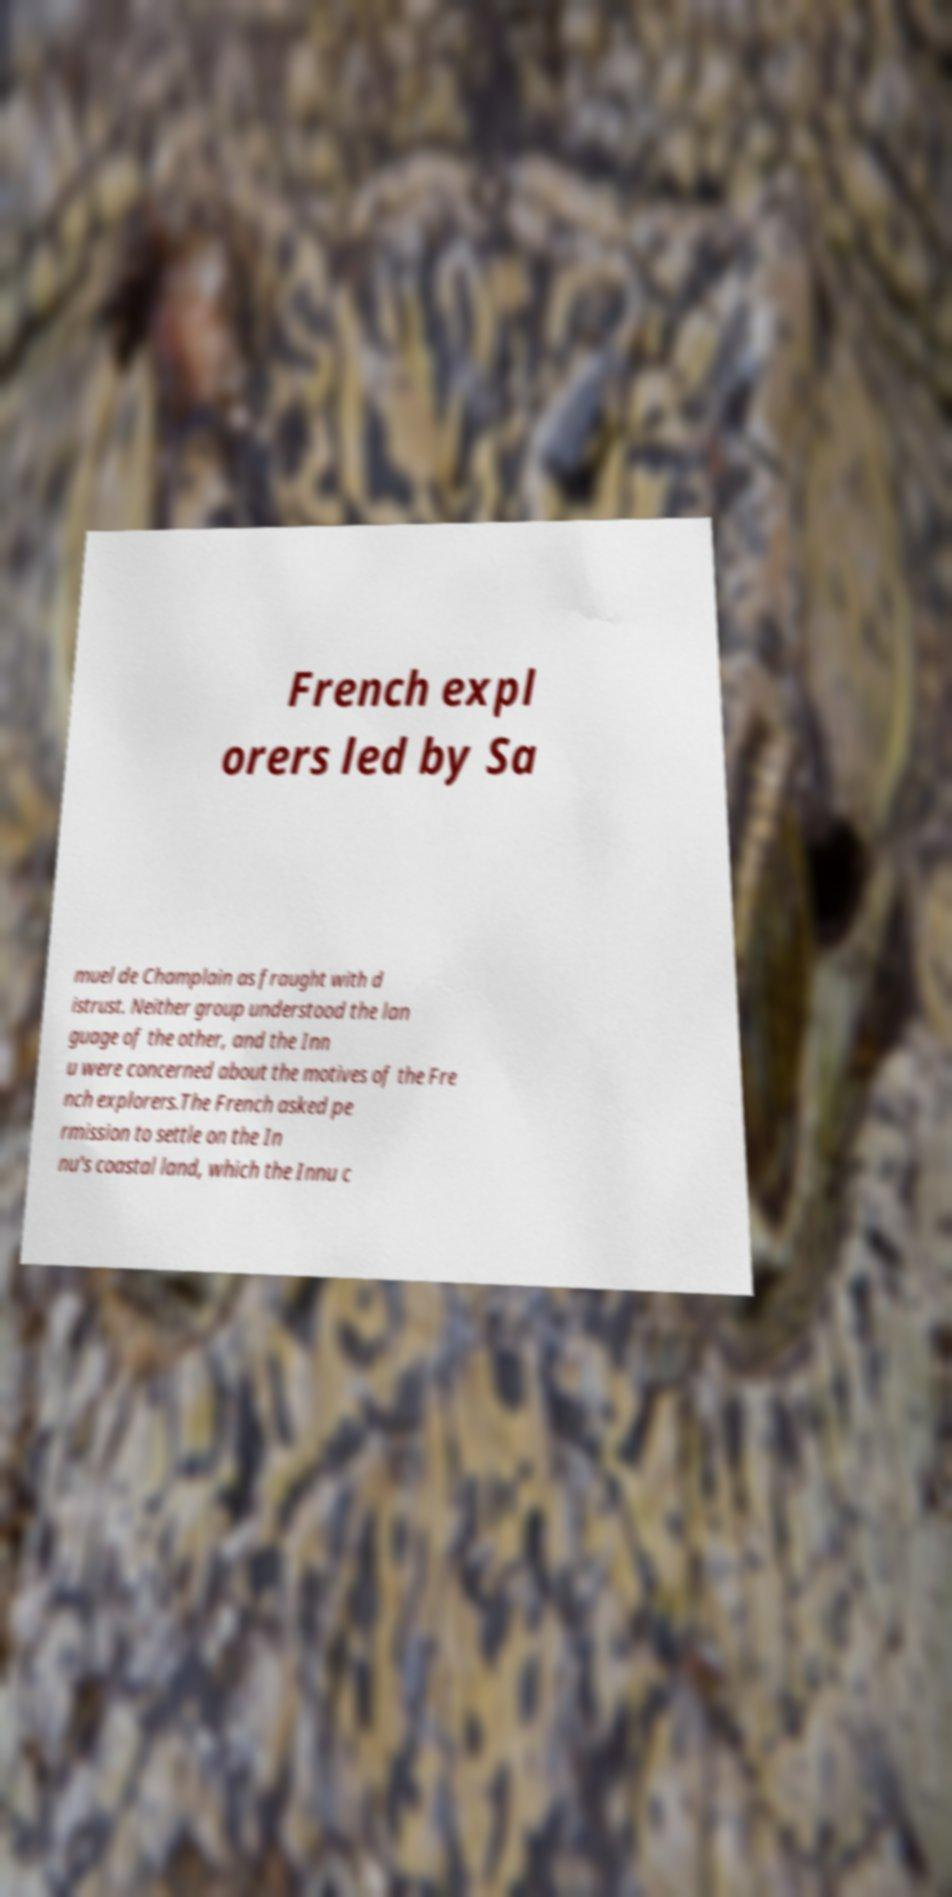Please identify and transcribe the text found in this image. French expl orers led by Sa muel de Champlain as fraught with d istrust. Neither group understood the lan guage of the other, and the Inn u were concerned about the motives of the Fre nch explorers.The French asked pe rmission to settle on the In nu's coastal land, which the Innu c 